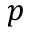<formula> <loc_0><loc_0><loc_500><loc_500>p</formula> 